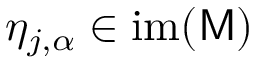Convert formula to latex. <formula><loc_0><loc_0><loc_500><loc_500>\eta _ { j , \alpha } \in i m ( M )</formula> 